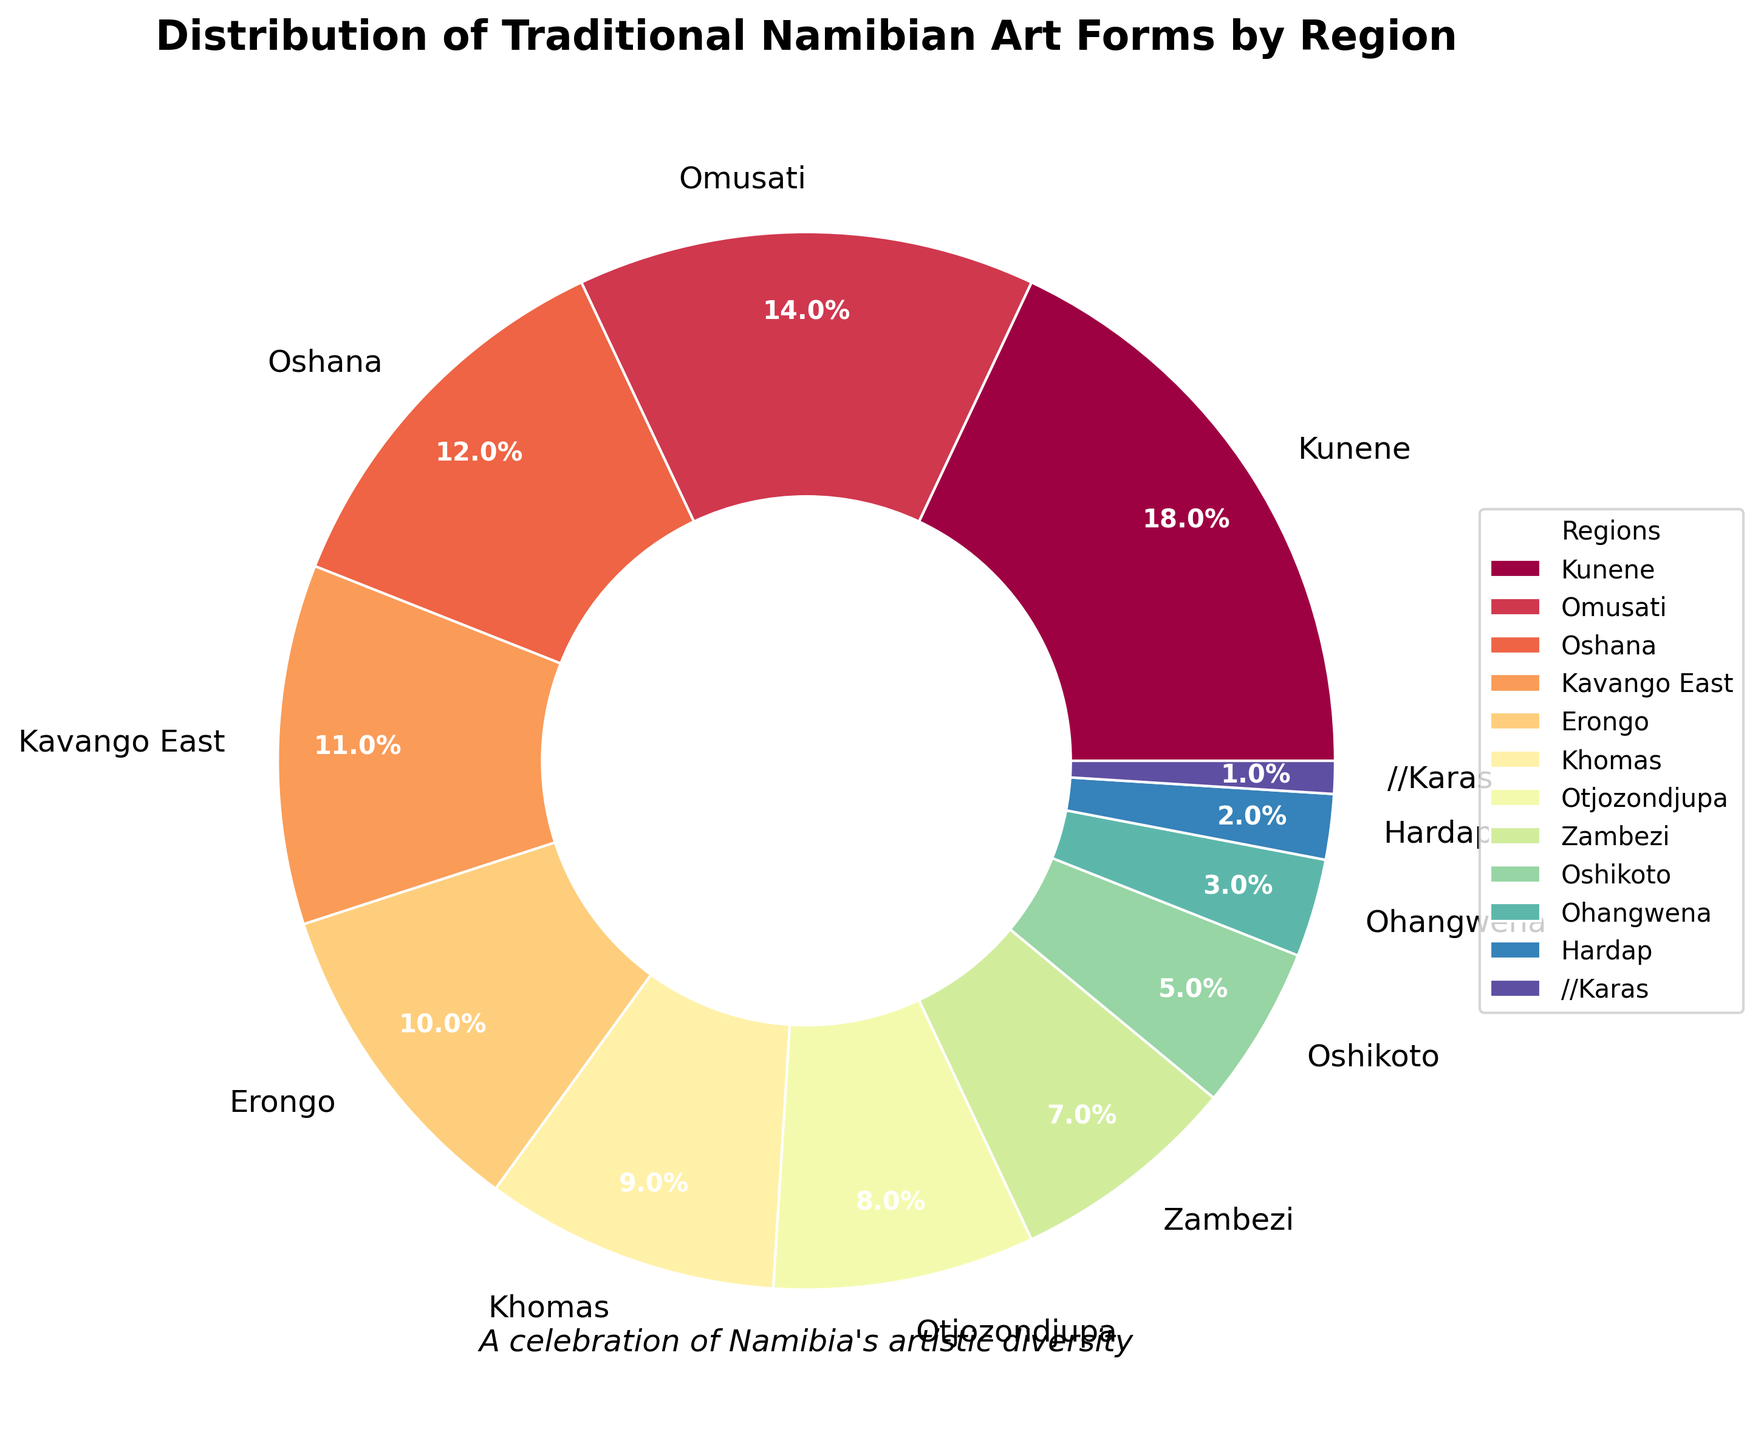What percentage of traditional Namibian art forms is represented by the Kunene and Omusati regions combined? To find the combined percentage, sum the percentages for Kunene (18%) and Omusati (14%). Therefore, 18% + 14% = 32%.
Answer: 32% Which region shows the lowest representation of traditional Namibian art forms? To determine the region with the lowest representation, look for the smallest percentage in the chart, which is the //Karas region at 1%.
Answer: //Karas Out of Hardap and Zambezi, which region has a higher percentage of traditional Namibian art forms? Compare the percentages for Hardap (2%) and Zambezi (7%). Zambezi has a higher percentage.
Answer: Zambezi How much more is the percentage of traditional Namibian art forms in Oshana compared to Oshikoto? Subtract the percentage of Oshikoto (5%) from Oshana (12%). Thus, 12% - 5% = 7%.
Answer: 7% What is the average percentage of traditional Namibian art forms for the regions of Khomas, Otjozondjupa, and Erongo? To find the average, sum the percentages of Khomas (9%), Otjozondjupa (8%), and Erongo (10%), then divide by the number of regions (3). Thus, (9% + 8% + 10%) / 3 = 27% / 3 = 9%.
Answer: 9% Which regions have a representation of traditional Namibian art forms greater than 10%? Identify the regions with percentages exceeding 10%. These are Kunene (18%), Omusati (14%), Oshana (12%), and Kavango East (11%).
Answer: Kunene, Omusati, Oshana, Kavango East Does the combined percentage of the bottom three regions equal the percentage of the Kunene region? Sum the percentages of the bottom three regions (Ohangwena 3%, Hardap 2%, //Karas 1%). Thus, 3% + 2% + 1% = 6%, which is less than Kunene's 18%.
Answer: No What visual cue distinguishes the largest segment on the pie chart? The largest segment, representing Kunene (18%), is visually distinguished by its relative size compared to other segments.
Answer: Size difference Compare the relative visual sizes of Otjozondjupa and Kavango East regions on the pie chart. Otjozondjupa (8%) is visually smaller than Kavango East (11%) due to the percentage difference.
Answer: Kavango East is larger 